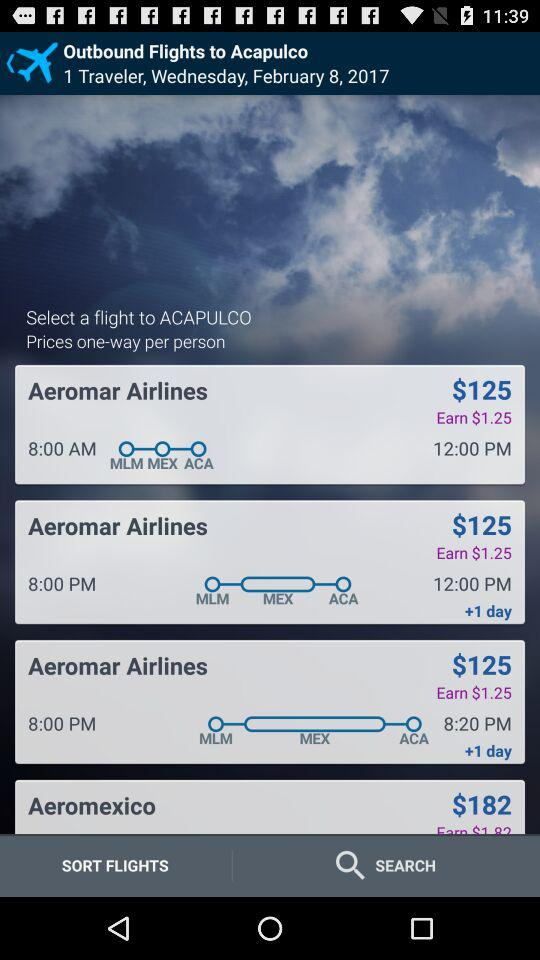What is the selected date and year? The selected date and year are Wednesday, February 8, 2017. 